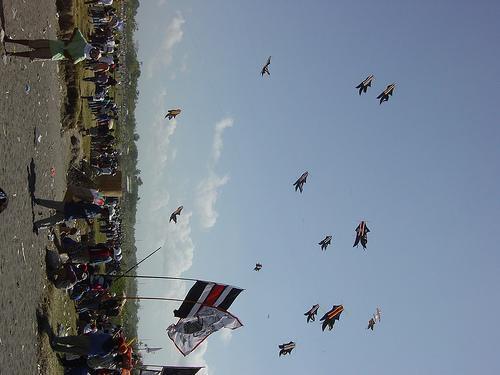How many kites are on air?
Give a very brief answer. 13. How many flags are there?
Give a very brief answer. 2. 